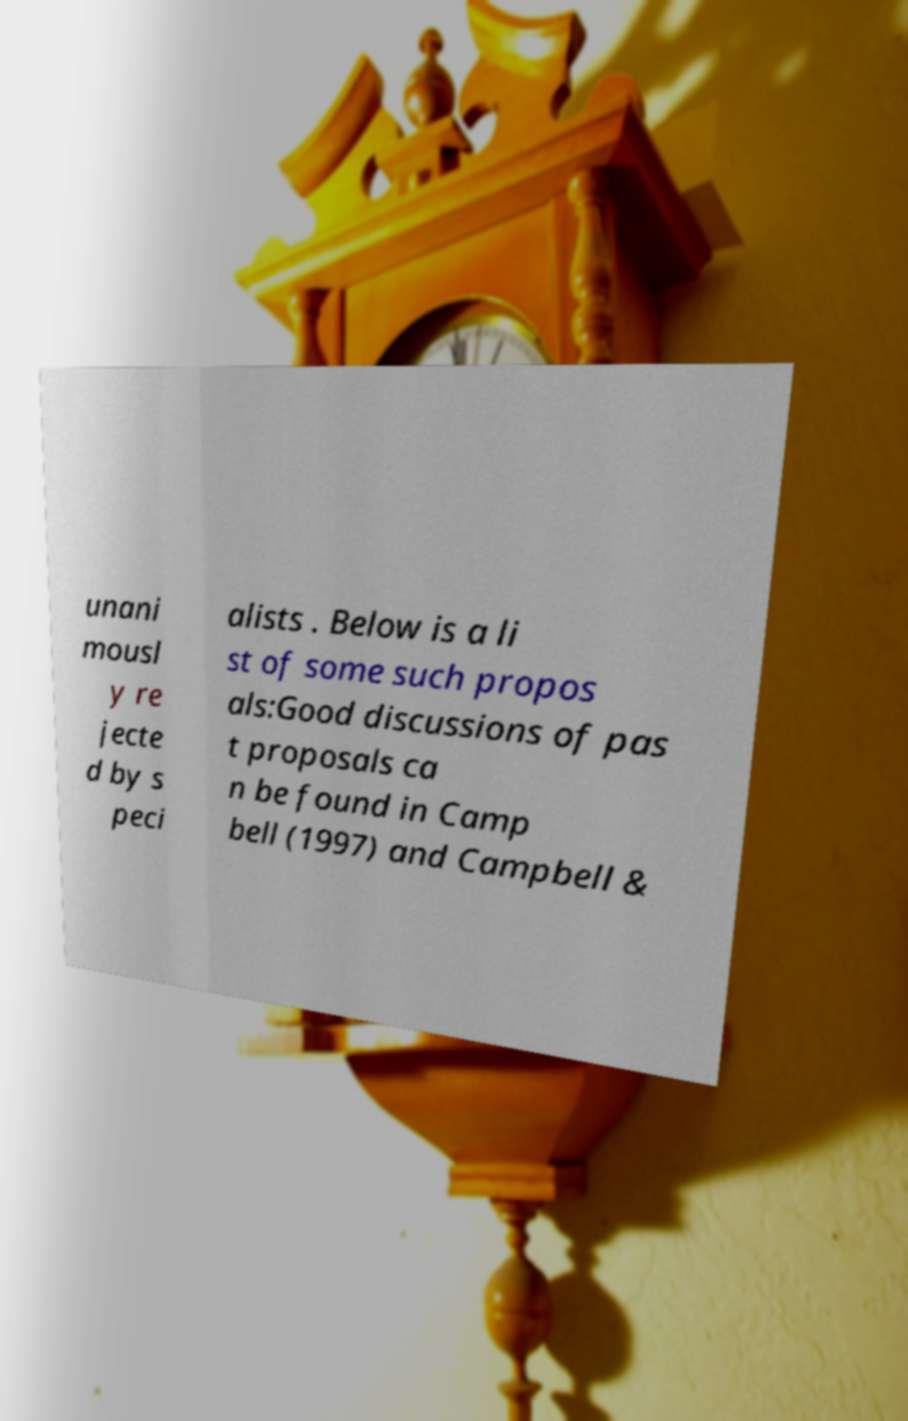For documentation purposes, I need the text within this image transcribed. Could you provide that? unani mousl y re jecte d by s peci alists . Below is a li st of some such propos als:Good discussions of pas t proposals ca n be found in Camp bell (1997) and Campbell & 